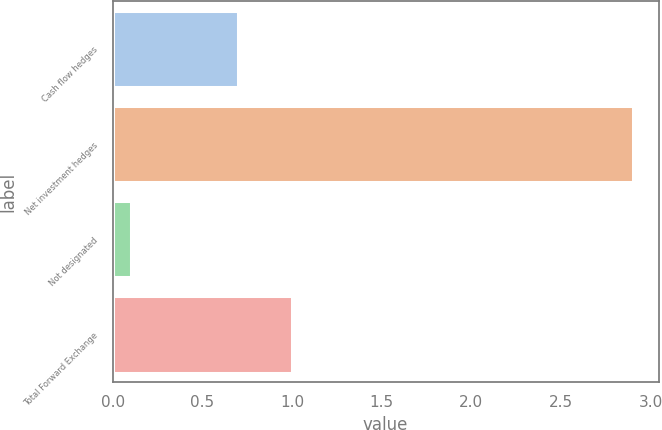<chart> <loc_0><loc_0><loc_500><loc_500><bar_chart><fcel>Cash flow hedges<fcel>Net investment hedges<fcel>Not designated<fcel>Total Forward Exchange<nl><fcel>0.7<fcel>2.9<fcel>0.1<fcel>1<nl></chart> 